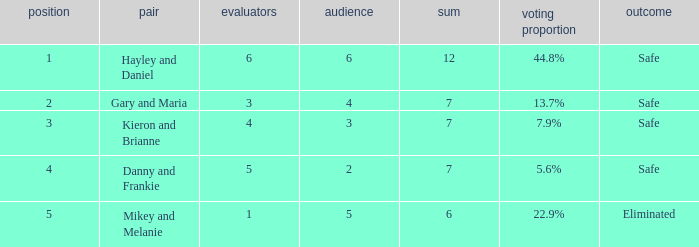What was the total number when the vote percentage was 44.8%? 1.0. 